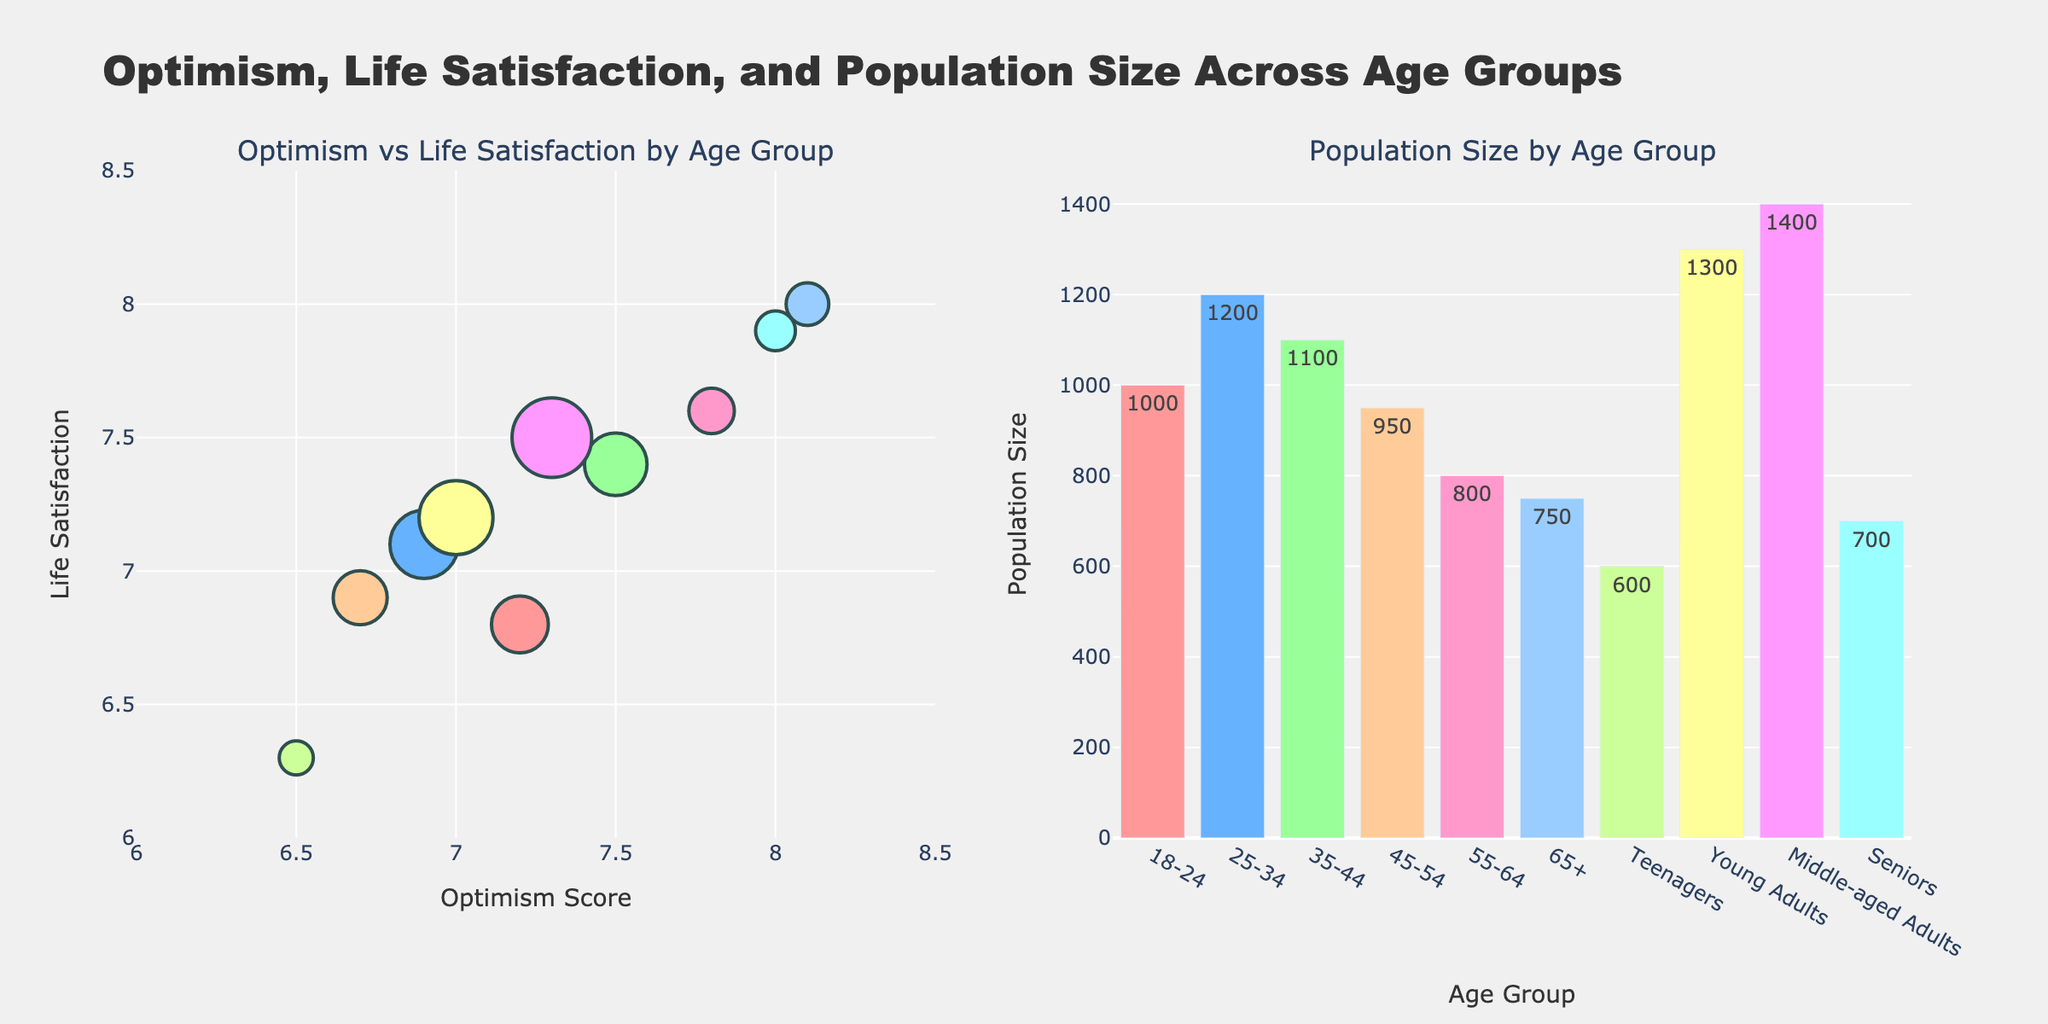Which age group has the highest optimism score? By looking at the first subplot, we can see that the "65+" age group is positioned the furthest to the right on the x-axis, indicating the highest optimism score.
Answer: 65+ What is the correlation between optimism scores and life satisfaction by age group? The first subplot shows a positive correlation where higher optimism scores seem to align with higher life satisfaction scores across different age groups.
Answer: Positive correlation Which age group has the largest population size? By examining the height of the bars in the second subplot, "Middle-aged Adults" has the tallest bar, indicating the largest population size.
Answer: Middle-aged Adults How does the life satisfaction score vary between "Teenagers" and "Seniors"? Checking the first subplot, "Teenagers" have a life satisfaction score of 6.3, while "Seniors" have a life satisfaction score of 7.9. Therefore, "Seniors" report significantly higher life satisfaction.
Answer: Seniors have higher life satisfaction What is the average optimism score for the age groups 18-24 and 25-34 combined? The optimism scores for 18-24 and 25-34 are 7.2 and 6.9, respectively. The average is calculated as (7.2 + 6.9) / 2 = 7.05.
Answer: 7.05 Which age group shows the lowest life satisfaction score? In the first subplot, "Teenagers" are positioned the lowest on the y-axis, indicating the lowest life satisfaction score.
Answer: Teenagers Compare the optimism score of "Young Adults" and "Middle-aged Adults". Which group is more optimistic? "Young Adults" have an optimism score of 7.0 while "Middle-aged Adults" have a score of 7.3. Therefore, "Middle-aged Adults" are more optimistic.
Answer: Middle-aged Adults Calculate the total population size for age groups with an optimism score above 7.5. The eligible age groups are 35-44, 55-64, 65+, and Seniors, with population sizes 1100, 800, 750, and 700, respectively. Summing these values gives 1100 + 800 + 750 + 700 = 3350.
Answer: 3350 Analyze the life satisfaction scores for "45-54" and "55-64" age groups. How do they compare? "45-54" has a life satisfaction score of 6.9 while "55-64" has a score of 7.6. Thus, "55-64" reports higher life satisfaction.
Answer: 55-64 has higher life satisfaction 